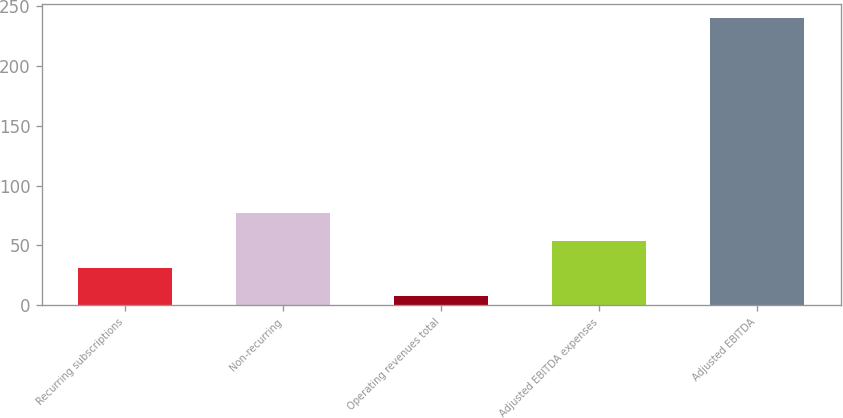Convert chart. <chart><loc_0><loc_0><loc_500><loc_500><bar_chart><fcel>Recurring subscriptions<fcel>Non-recurring<fcel>Operating revenues total<fcel>Adjusted EBITDA expenses<fcel>Adjusted EBITDA<nl><fcel>30.68<fcel>77.24<fcel>7.4<fcel>53.96<fcel>240.2<nl></chart> 